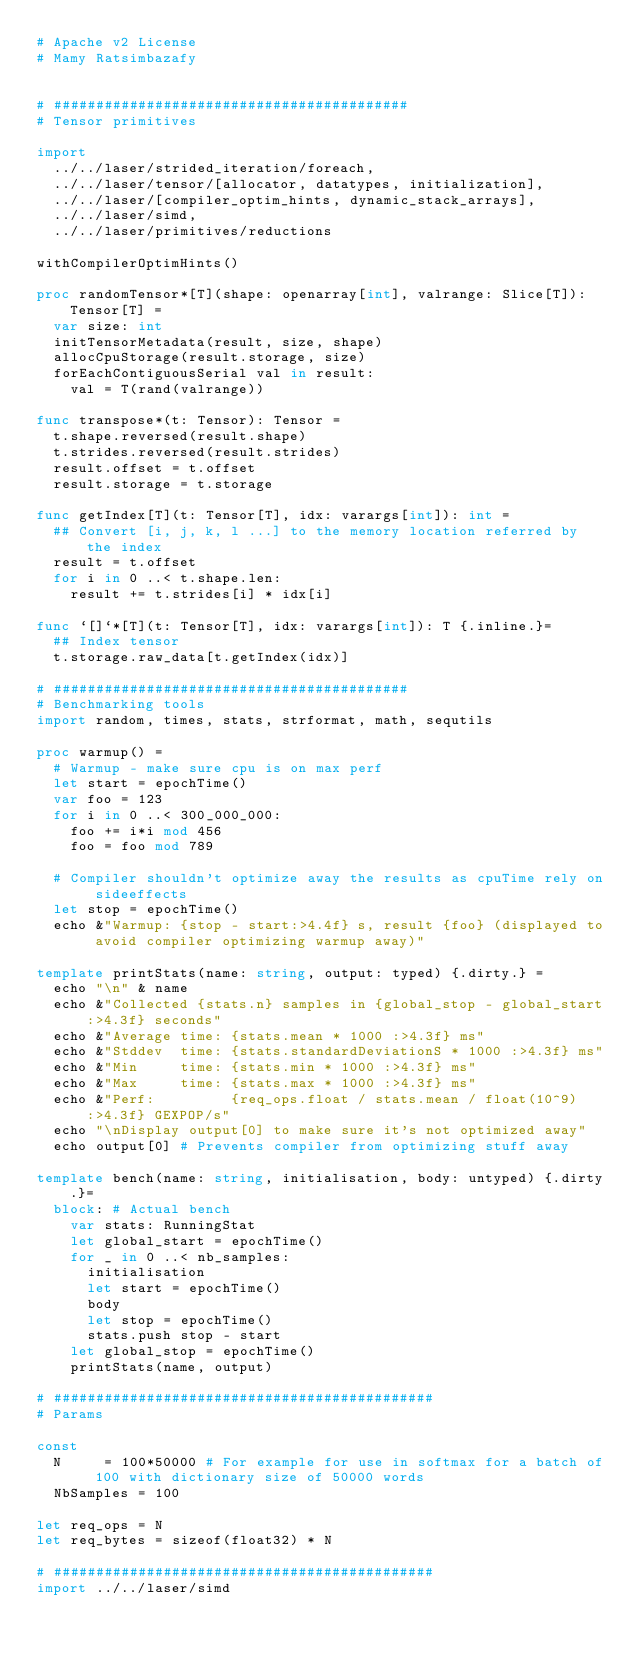<code> <loc_0><loc_0><loc_500><loc_500><_Nim_># Apache v2 License
# Mamy Ratsimbazafy


# ##########################################
# Tensor primitives

import
  ../../laser/strided_iteration/foreach,
  ../../laser/tensor/[allocator, datatypes, initialization],
  ../../laser/[compiler_optim_hints, dynamic_stack_arrays],
  ../../laser/simd,
  ../../laser/primitives/reductions

withCompilerOptimHints()

proc randomTensor*[T](shape: openarray[int], valrange: Slice[T]): Tensor[T] =
  var size: int
  initTensorMetadata(result, size, shape)
  allocCpuStorage(result.storage, size)
  forEachContiguousSerial val in result:
    val = T(rand(valrange))

func transpose*(t: Tensor): Tensor =
  t.shape.reversed(result.shape)
  t.strides.reversed(result.strides)
  result.offset = t.offset
  result.storage = t.storage

func getIndex[T](t: Tensor[T], idx: varargs[int]): int =
  ## Convert [i, j, k, l ...] to the memory location referred by the index
  result = t.offset
  for i in 0 ..< t.shape.len:
    result += t.strides[i] * idx[i]

func `[]`*[T](t: Tensor[T], idx: varargs[int]): T {.inline.}=
  ## Index tensor
  t.storage.raw_data[t.getIndex(idx)]

# ##########################################
# Benchmarking tools
import random, times, stats, strformat, math, sequtils

proc warmup() =
  # Warmup - make sure cpu is on max perf
  let start = epochTime()
  var foo = 123
  for i in 0 ..< 300_000_000:
    foo += i*i mod 456
    foo = foo mod 789

  # Compiler shouldn't optimize away the results as cpuTime rely on sideeffects
  let stop = epochTime()
  echo &"Warmup: {stop - start:>4.4f} s, result {foo} (displayed to avoid compiler optimizing warmup away)"

template printStats(name: string, output: typed) {.dirty.} =
  echo "\n" & name
  echo &"Collected {stats.n} samples in {global_stop - global_start:>4.3f} seconds"
  echo &"Average time: {stats.mean * 1000 :>4.3f} ms"
  echo &"Stddev  time: {stats.standardDeviationS * 1000 :>4.3f} ms"
  echo &"Min     time: {stats.min * 1000 :>4.3f} ms"
  echo &"Max     time: {stats.max * 1000 :>4.3f} ms"
  echo &"Perf:         {req_ops.float / stats.mean / float(10^9):>4.3f} GEXPOP/s"
  echo "\nDisplay output[0] to make sure it's not optimized away"
  echo output[0] # Prevents compiler from optimizing stuff away

template bench(name: string, initialisation, body: untyped) {.dirty.}=
  block: # Actual bench
    var stats: RunningStat
    let global_start = epochTime()
    for _ in 0 ..< nb_samples:
      initialisation
      let start = epochTime()
      body
      let stop = epochTime()
      stats.push stop - start
    let global_stop = epochTime()
    printStats(name, output)

# #############################################
# Params

const
  N     = 100*50000 # For example for use in softmax for a batch of 100 with dictionary size of 50000 words
  NbSamples = 100

let req_ops = N
let req_bytes = sizeof(float32) * N

# #############################################
import ../../laser/simd
</code> 